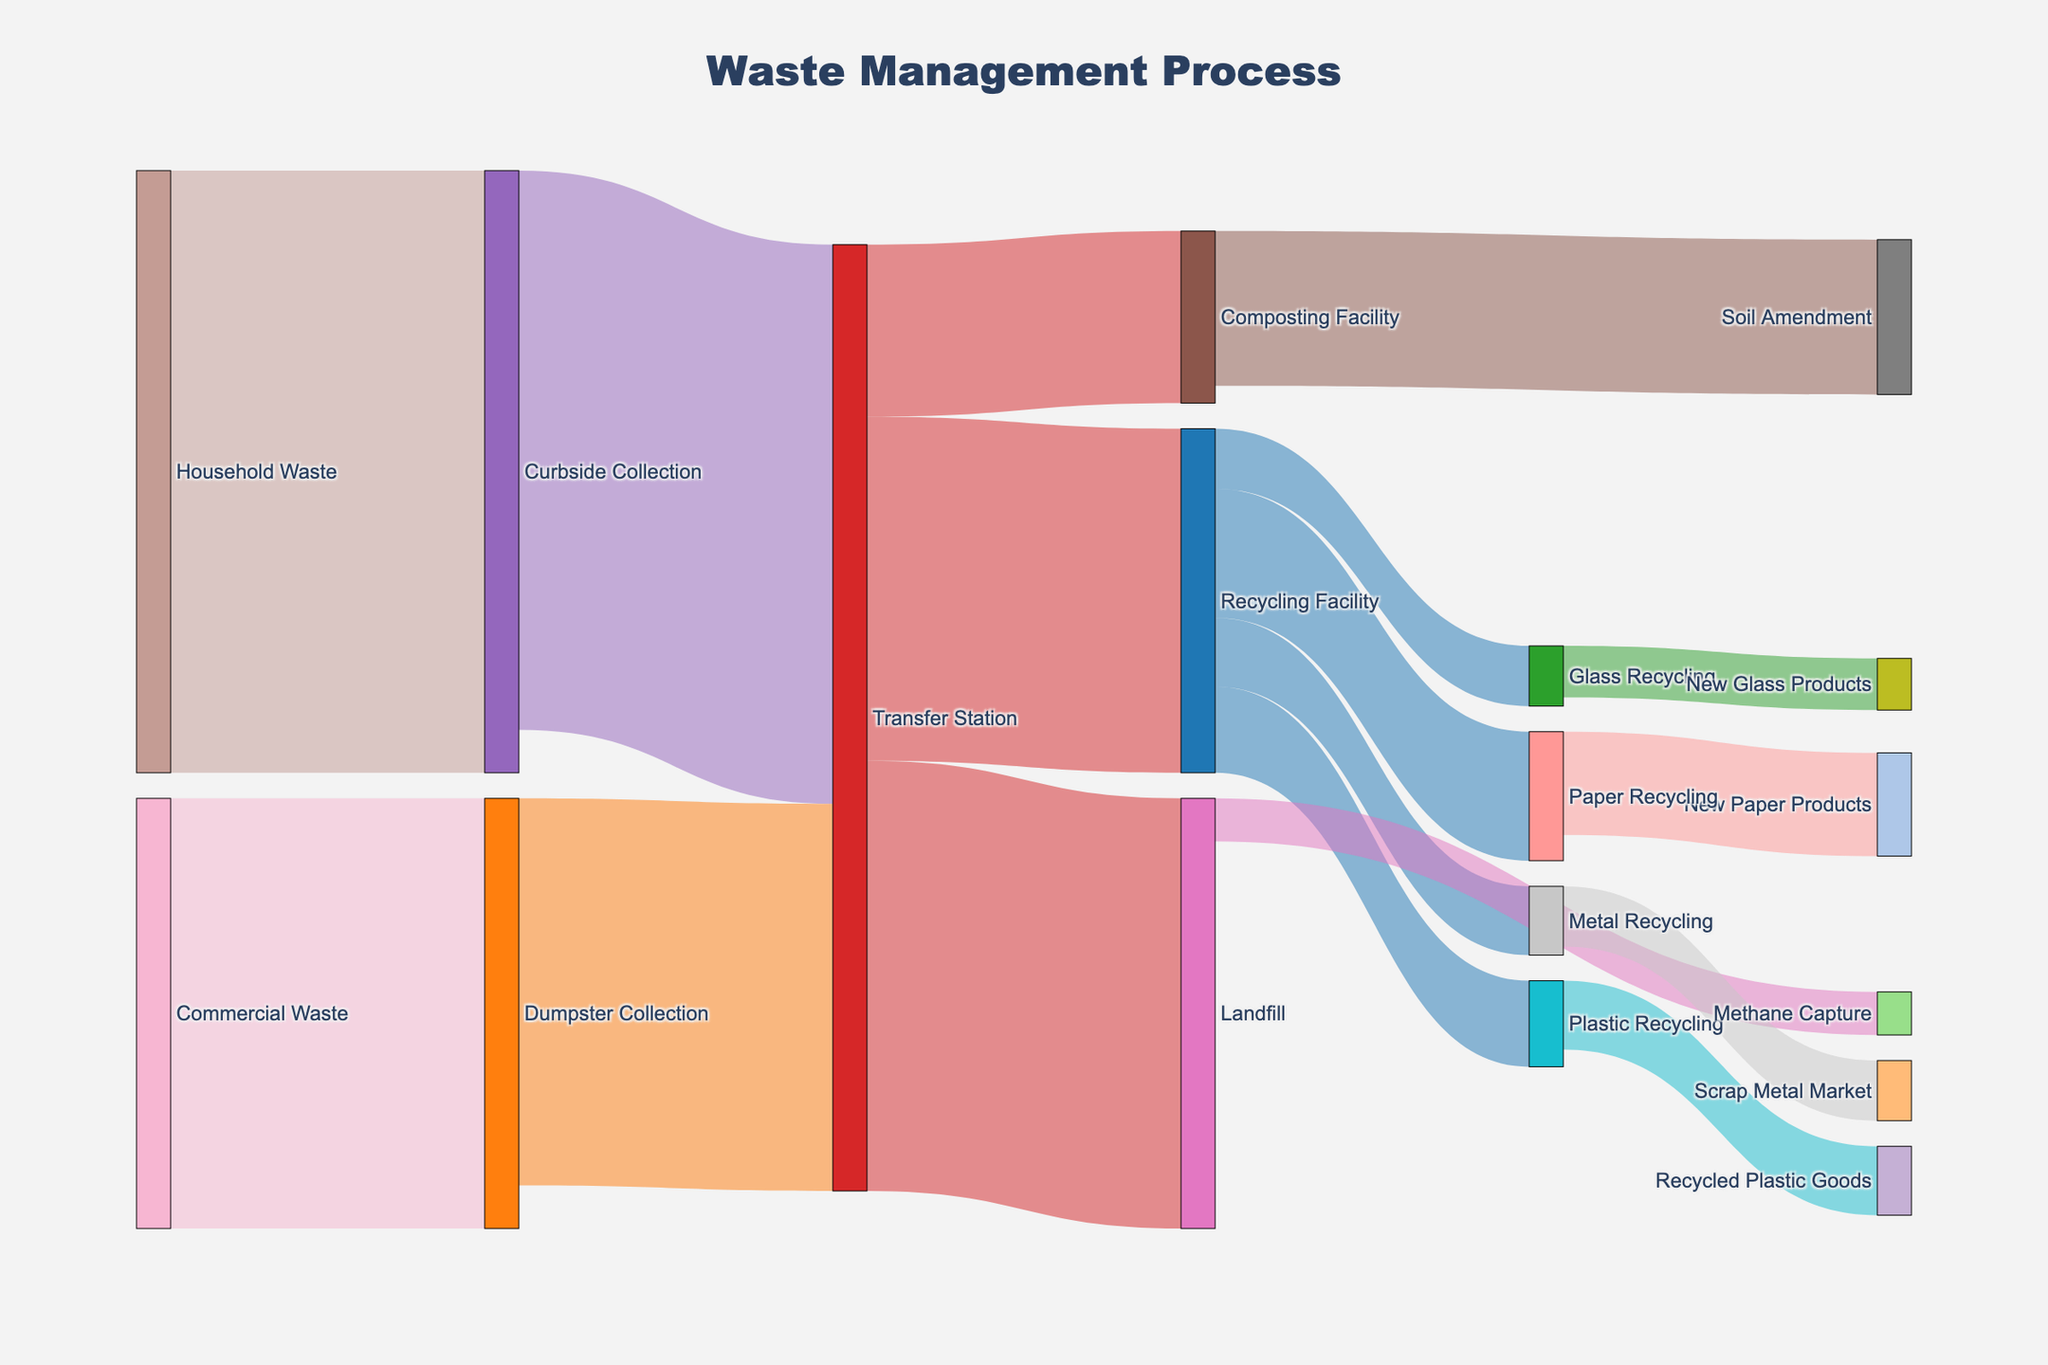How many types of waste collection methods are shown in the diagram? The diagram shows Household Waste and Commercial Waste being collected via Curbside Collection and Dumpster Collection respectively.
Answer: 2 Which destination receives the highest amount of waste from the Transfer Station? The Transfer Station sends 50 units to the Landfill, 40 units to the Recycling Facility, and 20 units to the Composting Facility. Therefore, the Landfill receives the highest amount.
Answer: Landfill What is the total amount of waste processed by the Transfer Station? The Transfer Station processes waste from Curbside Collection (65) and Dumpster Collection (45). The total is 65 + 45.
Answer: 110 How does the amount of waste going to Landfill compare to that going to Recycling Facility from the Transfer Station? The Landfill receives 50 units and the Recycling Facility receives 40 units from the Transfer Station. 50 is greater than 40.
Answer: More What types of recycling are shown in the diagram? The Recycling Facility processes waste into Paper Recycling, Plastic Recycling, Metal Recycling, and Glass Recycling.
Answer: 4 types What is the final product associated with Plastic Recycling? Plastic Recycling leads to Recycled Plastic Goods.
Answer: Recycled Plastic Goods How many end products are derived from the Recycling Facility? List them. The Recycling Facility produces items from Paper, Plastic, Metal, and Glass recycling, leading to New Paper Products, Recycled Plastic Goods, Scrap Metal Market, and New Glass Products. So there are four end products.
Answer: 4; New Paper Products, Recycled Plastic Goods, Scrap Metal Market, New Glass Products What is the combined amount of waste processed by Composting Facility and Methane Capture? Composting Facility processes 20 units, and Methane Capture processes 5 units. Total is 20 + 5.
Answer: 25 Which process has the smallest flow of waste from the Transfer Station? The smallest flow from the Transfer Station is to the Composting Facility, which receives 20 units.
Answer: Composting Facility What is the total amount of waste recycled at the Recycling Facility? The Recycling Facility processes 40 units from the Transfer Station.
Answer: 40 